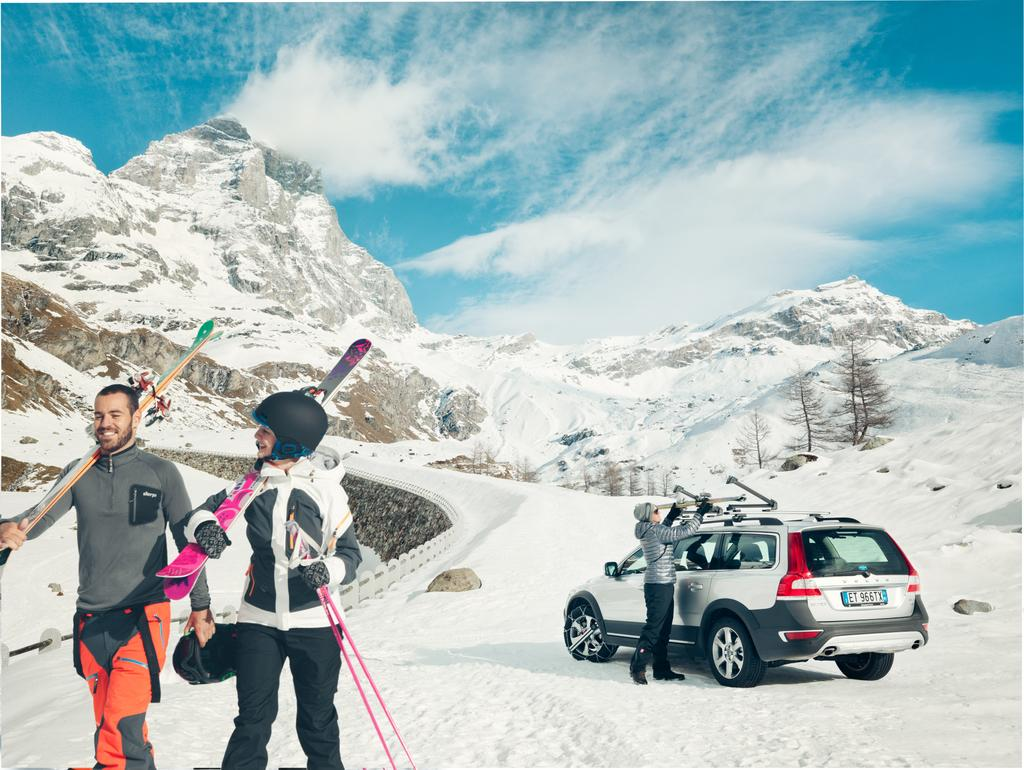How many people are in the image? There is a group of people in the image, but the exact number cannot be determined from the provided facts. What type of vehicle is present in the image? There is a vehicle in the image, but its specific type cannot be determined from the provided facts. What can be seen in the background of the image? Mountains and the sky are visible in the background of the image. What type of club can be seen in the hands of the people in the image? There is no club present in the image; it features a group of people and a vehicle with mountains and the sky in the background. 